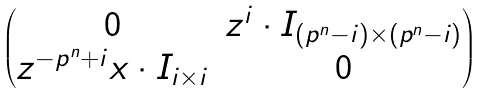<formula> <loc_0><loc_0><loc_500><loc_500>\begin{pmatrix} 0 & z ^ { i } \cdot I _ { ( p ^ { n } - i ) \times ( p ^ { n } - i ) } \\ z ^ { - p ^ { n } + i } x \cdot I _ { i \times i } & 0 \end{pmatrix}</formula> 